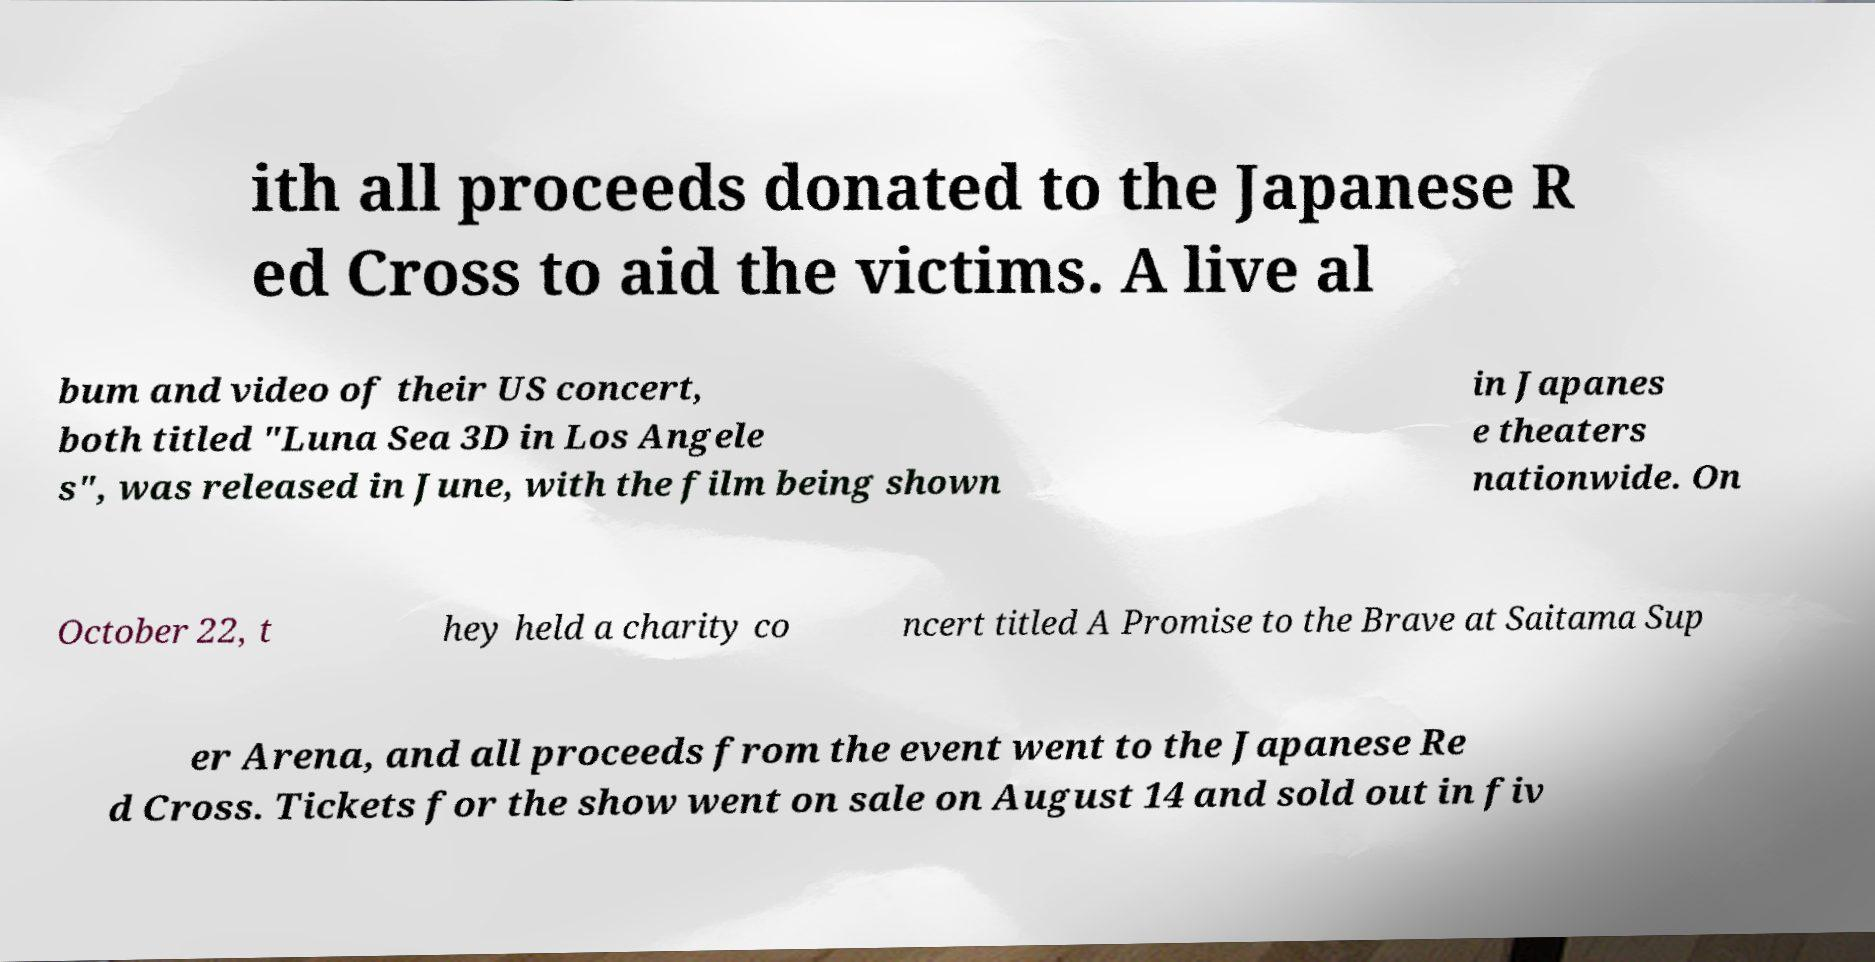Please read and relay the text visible in this image. What does it say? ith all proceeds donated to the Japanese R ed Cross to aid the victims. A live al bum and video of their US concert, both titled "Luna Sea 3D in Los Angele s", was released in June, with the film being shown in Japanes e theaters nationwide. On October 22, t hey held a charity co ncert titled A Promise to the Brave at Saitama Sup er Arena, and all proceeds from the event went to the Japanese Re d Cross. Tickets for the show went on sale on August 14 and sold out in fiv 